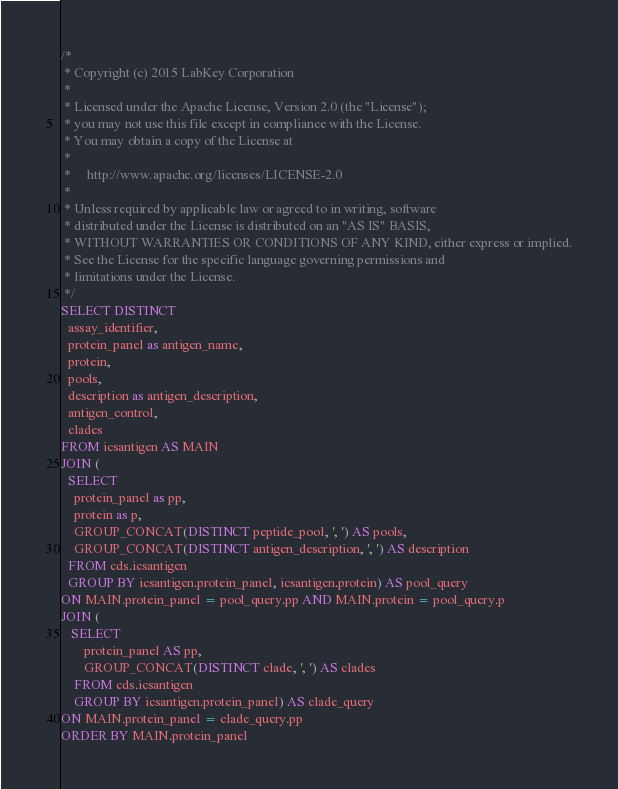Convert code to text. <code><loc_0><loc_0><loc_500><loc_500><_SQL_>/*
 * Copyright (c) 2015 LabKey Corporation
 *
 * Licensed under the Apache License, Version 2.0 (the "License");
 * you may not use this file except in compliance with the License.
 * You may obtain a copy of the License at
 *
 *     http://www.apache.org/licenses/LICENSE-2.0
 *
 * Unless required by applicable law or agreed to in writing, software
 * distributed under the License is distributed on an "AS IS" BASIS,
 * WITHOUT WARRANTIES OR CONDITIONS OF ANY KIND, either express or implied.
 * See the License for the specific language governing permissions and
 * limitations under the License.
 */
SELECT DISTINCT
  assay_identifier,
  protein_panel as antigen_name,
  protein,
  pools,
  description as antigen_description,
  antigen_control,
  clades
FROM icsantigen AS MAIN
JOIN (
  SELECT
    protein_panel as pp,
   	protein as p,
    GROUP_CONCAT(DISTINCT peptide_pool, ', ') AS pools,
    GROUP_CONCAT(DISTINCT antigen_description, ', ') AS description
  FROM cds.icsantigen
  GROUP BY icsantigen.protein_panel, icsantigen.protein) AS pool_query
ON MAIN.protein_panel = pool_query.pp AND MAIN.protein = pool_query.p
JOIN (
   SELECT
       protein_panel AS pp,
       GROUP_CONCAT(DISTINCT clade, ', ') AS clades
	FROM cds.icsantigen
	GROUP BY icsantigen.protein_panel) AS clade_query
ON MAIN.protein_panel = clade_query.pp
ORDER BY MAIN.protein_panel</code> 